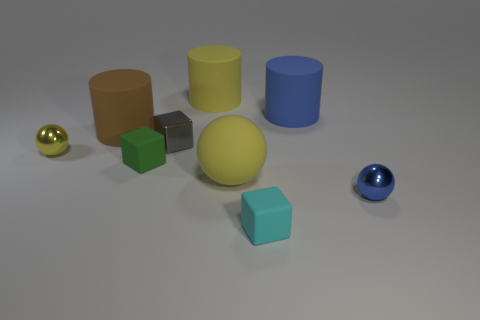Are there the same number of blue metallic objects that are behind the small shiny block and big brown cylinders that are left of the cyan block?
Ensure brevity in your answer.  No. Do the small sphere that is to the right of the small green object and the yellow sphere that is left of the brown rubber object have the same material?
Make the answer very short. Yes. What is the blue cylinder made of?
Ensure brevity in your answer.  Rubber. How many other things are the same color as the metallic block?
Offer a terse response. 0. Do the tiny metallic cube and the rubber sphere have the same color?
Provide a succinct answer. No. How many tiny metallic balls are there?
Ensure brevity in your answer.  2. What is the material of the sphere that is on the right side of the blue object that is left of the blue shiny thing?
Ensure brevity in your answer.  Metal. What is the material of the blue sphere that is the same size as the green cube?
Offer a very short reply. Metal. Does the metal thing in front of the yellow shiny object have the same size as the cyan rubber object?
Make the answer very short. Yes. There is a tiny green thing that is in front of the large brown matte cylinder; does it have the same shape as the small gray thing?
Make the answer very short. Yes. 